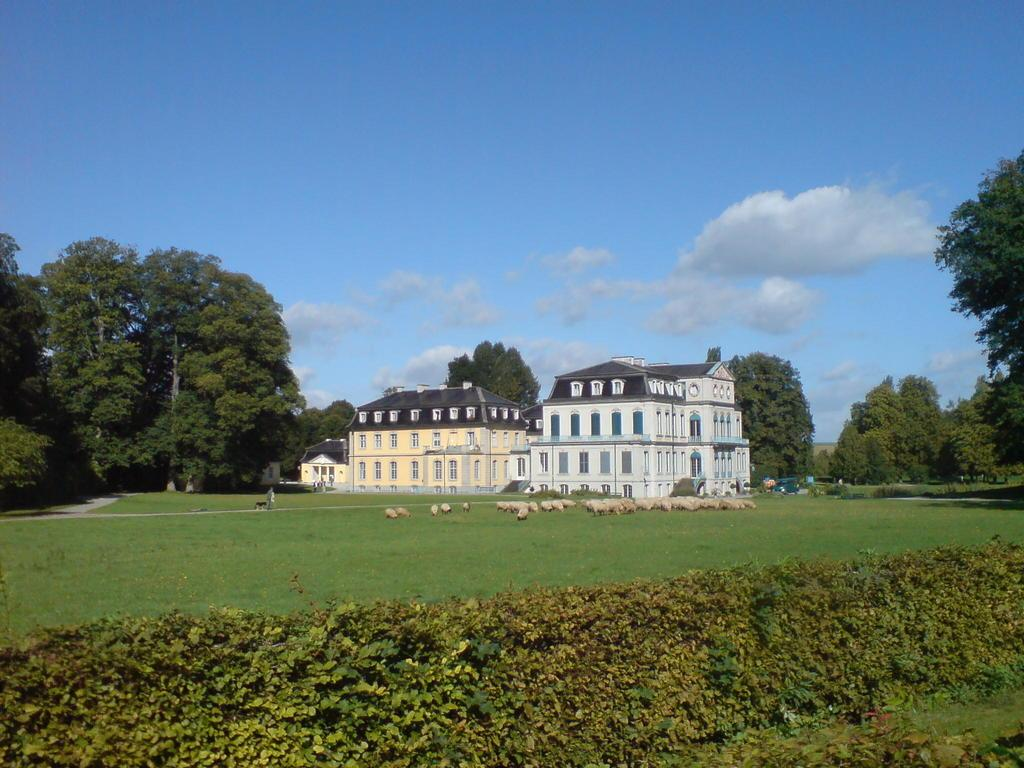What type of living organisms can be seen in the image? Plants and animals are visible in the image. Where are the animals located in the image? The animals are on the grass in the image. What type of structures can be seen in the image? There are buildings in the image. What type of vegetation is present at the back of the image? There are trees at the back of the image. Can you see the cook preparing a meal in the image? There is no cook or meal preparation visible in the image. What type of wing is present in the image? There is no wing present in the image. 